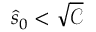Convert formula to latex. <formula><loc_0><loc_0><loc_500><loc_500>\hat { s } _ { 0 } < \sqrt { \mathcal { C } }</formula> 